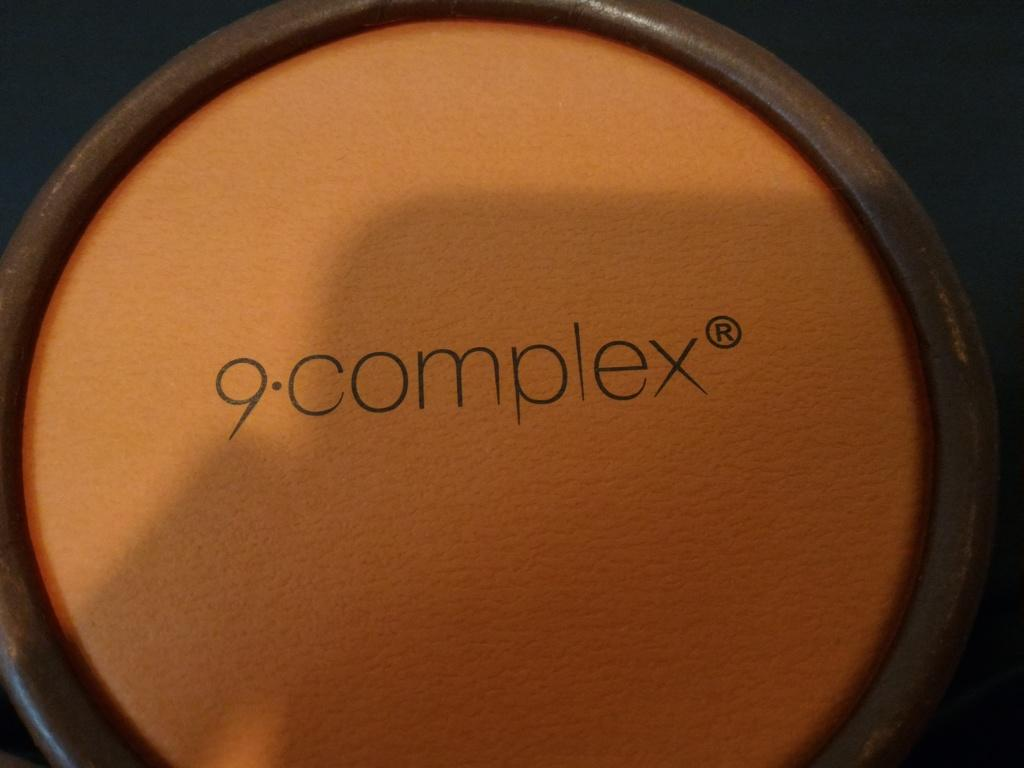<image>
Describe the image concisely. a light brown circle with 9-complex written on it surrounded by a dark brown outline 